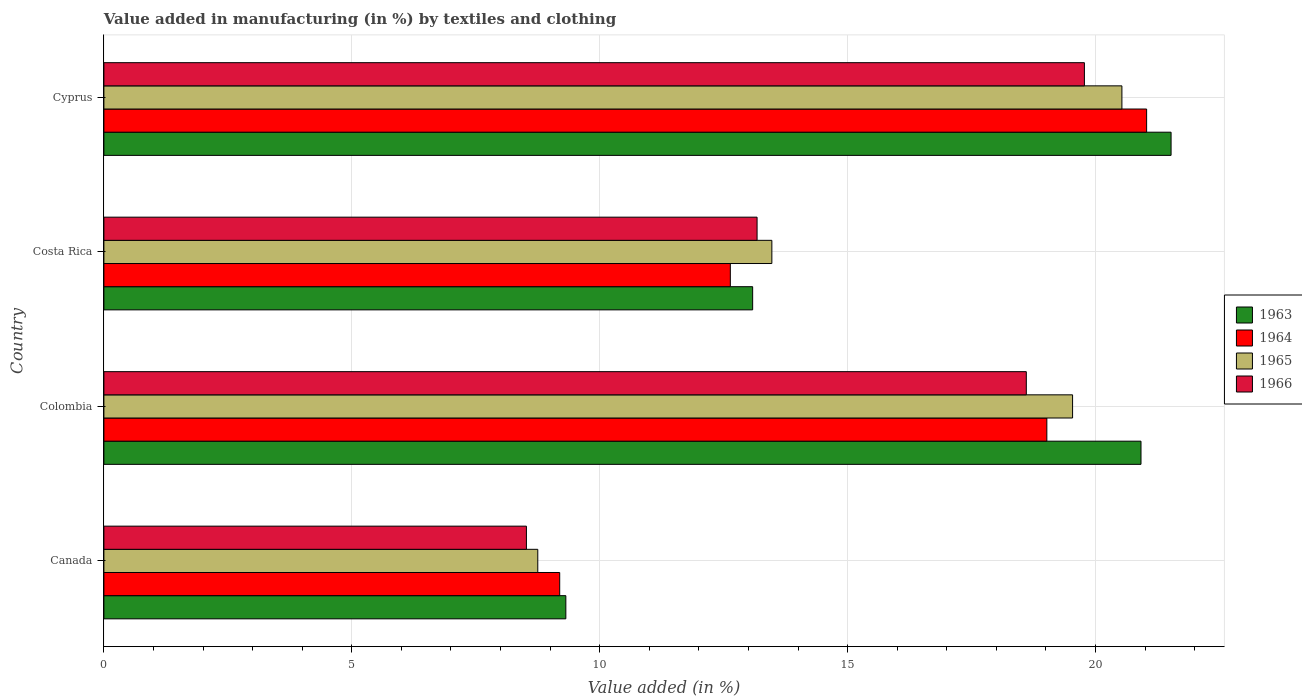How many different coloured bars are there?
Your answer should be very brief. 4. Are the number of bars per tick equal to the number of legend labels?
Give a very brief answer. Yes. How many bars are there on the 1st tick from the top?
Give a very brief answer. 4. What is the label of the 1st group of bars from the top?
Provide a short and direct response. Cyprus. What is the percentage of value added in manufacturing by textiles and clothing in 1965 in Cyprus?
Your answer should be very brief. 20.53. Across all countries, what is the maximum percentage of value added in manufacturing by textiles and clothing in 1965?
Your answer should be very brief. 20.53. Across all countries, what is the minimum percentage of value added in manufacturing by textiles and clothing in 1964?
Give a very brief answer. 9.19. In which country was the percentage of value added in manufacturing by textiles and clothing in 1965 maximum?
Ensure brevity in your answer.  Cyprus. What is the total percentage of value added in manufacturing by textiles and clothing in 1965 in the graph?
Offer a very short reply. 62.29. What is the difference between the percentage of value added in manufacturing by textiles and clothing in 1966 in Canada and that in Costa Rica?
Ensure brevity in your answer.  -4.65. What is the difference between the percentage of value added in manufacturing by textiles and clothing in 1964 in Cyprus and the percentage of value added in manufacturing by textiles and clothing in 1963 in Costa Rica?
Your response must be concise. 7.95. What is the average percentage of value added in manufacturing by textiles and clothing in 1964 per country?
Give a very brief answer. 15.47. What is the difference between the percentage of value added in manufacturing by textiles and clothing in 1963 and percentage of value added in manufacturing by textiles and clothing in 1964 in Costa Rica?
Offer a very short reply. 0.45. What is the ratio of the percentage of value added in manufacturing by textiles and clothing in 1966 in Canada to that in Colombia?
Offer a terse response. 0.46. Is the percentage of value added in manufacturing by textiles and clothing in 1966 in Canada less than that in Cyprus?
Ensure brevity in your answer.  Yes. What is the difference between the highest and the second highest percentage of value added in manufacturing by textiles and clothing in 1964?
Offer a very short reply. 2.01. What is the difference between the highest and the lowest percentage of value added in manufacturing by textiles and clothing in 1966?
Your answer should be compact. 11.25. In how many countries, is the percentage of value added in manufacturing by textiles and clothing in 1963 greater than the average percentage of value added in manufacturing by textiles and clothing in 1963 taken over all countries?
Keep it short and to the point. 2. What does the 1st bar from the top in Colombia represents?
Make the answer very short. 1966. What does the 2nd bar from the bottom in Colombia represents?
Provide a succinct answer. 1964. Is it the case that in every country, the sum of the percentage of value added in manufacturing by textiles and clothing in 1964 and percentage of value added in manufacturing by textiles and clothing in 1965 is greater than the percentage of value added in manufacturing by textiles and clothing in 1966?
Give a very brief answer. Yes. Are all the bars in the graph horizontal?
Provide a succinct answer. Yes. What is the difference between two consecutive major ticks on the X-axis?
Your response must be concise. 5. Are the values on the major ticks of X-axis written in scientific E-notation?
Your answer should be compact. No. Does the graph contain any zero values?
Provide a succinct answer. No. Does the graph contain grids?
Offer a terse response. Yes. How are the legend labels stacked?
Your answer should be very brief. Vertical. What is the title of the graph?
Give a very brief answer. Value added in manufacturing (in %) by textiles and clothing. Does "1978" appear as one of the legend labels in the graph?
Give a very brief answer. No. What is the label or title of the X-axis?
Provide a succinct answer. Value added (in %). What is the label or title of the Y-axis?
Offer a terse response. Country. What is the Value added (in %) in 1963 in Canada?
Ensure brevity in your answer.  9.32. What is the Value added (in %) in 1964 in Canada?
Ensure brevity in your answer.  9.19. What is the Value added (in %) of 1965 in Canada?
Offer a very short reply. 8.75. What is the Value added (in %) in 1966 in Canada?
Provide a succinct answer. 8.52. What is the Value added (in %) of 1963 in Colombia?
Ensure brevity in your answer.  20.92. What is the Value added (in %) of 1964 in Colombia?
Provide a succinct answer. 19.02. What is the Value added (in %) of 1965 in Colombia?
Give a very brief answer. 19.54. What is the Value added (in %) in 1966 in Colombia?
Offer a very short reply. 18.6. What is the Value added (in %) in 1963 in Costa Rica?
Your response must be concise. 13.08. What is the Value added (in %) of 1964 in Costa Rica?
Provide a succinct answer. 12.63. What is the Value added (in %) of 1965 in Costa Rica?
Your answer should be compact. 13.47. What is the Value added (in %) in 1966 in Costa Rica?
Provide a short and direct response. 13.17. What is the Value added (in %) in 1963 in Cyprus?
Provide a short and direct response. 21.52. What is the Value added (in %) of 1964 in Cyprus?
Your answer should be compact. 21.03. What is the Value added (in %) of 1965 in Cyprus?
Ensure brevity in your answer.  20.53. What is the Value added (in %) of 1966 in Cyprus?
Keep it short and to the point. 19.78. Across all countries, what is the maximum Value added (in %) in 1963?
Offer a very short reply. 21.52. Across all countries, what is the maximum Value added (in %) in 1964?
Your answer should be very brief. 21.03. Across all countries, what is the maximum Value added (in %) in 1965?
Make the answer very short. 20.53. Across all countries, what is the maximum Value added (in %) of 1966?
Provide a succinct answer. 19.78. Across all countries, what is the minimum Value added (in %) of 1963?
Provide a succinct answer. 9.32. Across all countries, what is the minimum Value added (in %) of 1964?
Your response must be concise. 9.19. Across all countries, what is the minimum Value added (in %) of 1965?
Ensure brevity in your answer.  8.75. Across all countries, what is the minimum Value added (in %) in 1966?
Keep it short and to the point. 8.52. What is the total Value added (in %) in 1963 in the graph?
Give a very brief answer. 64.84. What is the total Value added (in %) of 1964 in the graph?
Make the answer very short. 61.88. What is the total Value added (in %) of 1965 in the graph?
Your answer should be very brief. 62.29. What is the total Value added (in %) in 1966 in the graph?
Provide a succinct answer. 60.08. What is the difference between the Value added (in %) in 1963 in Canada and that in Colombia?
Your response must be concise. -11.6. What is the difference between the Value added (in %) in 1964 in Canada and that in Colombia?
Give a very brief answer. -9.82. What is the difference between the Value added (in %) of 1965 in Canada and that in Colombia?
Your answer should be very brief. -10.79. What is the difference between the Value added (in %) of 1966 in Canada and that in Colombia?
Offer a very short reply. -10.08. What is the difference between the Value added (in %) of 1963 in Canada and that in Costa Rica?
Your answer should be very brief. -3.77. What is the difference between the Value added (in %) of 1964 in Canada and that in Costa Rica?
Offer a very short reply. -3.44. What is the difference between the Value added (in %) of 1965 in Canada and that in Costa Rica?
Make the answer very short. -4.72. What is the difference between the Value added (in %) of 1966 in Canada and that in Costa Rica?
Make the answer very short. -4.65. What is the difference between the Value added (in %) in 1963 in Canada and that in Cyprus?
Provide a succinct answer. -12.21. What is the difference between the Value added (in %) in 1964 in Canada and that in Cyprus?
Offer a terse response. -11.84. What is the difference between the Value added (in %) of 1965 in Canada and that in Cyprus?
Offer a terse response. -11.78. What is the difference between the Value added (in %) in 1966 in Canada and that in Cyprus?
Your answer should be compact. -11.25. What is the difference between the Value added (in %) of 1963 in Colombia and that in Costa Rica?
Ensure brevity in your answer.  7.83. What is the difference between the Value added (in %) in 1964 in Colombia and that in Costa Rica?
Provide a succinct answer. 6.38. What is the difference between the Value added (in %) in 1965 in Colombia and that in Costa Rica?
Offer a very short reply. 6.06. What is the difference between the Value added (in %) of 1966 in Colombia and that in Costa Rica?
Ensure brevity in your answer.  5.43. What is the difference between the Value added (in %) of 1963 in Colombia and that in Cyprus?
Make the answer very short. -0.61. What is the difference between the Value added (in %) of 1964 in Colombia and that in Cyprus?
Keep it short and to the point. -2.01. What is the difference between the Value added (in %) in 1965 in Colombia and that in Cyprus?
Offer a terse response. -0.99. What is the difference between the Value added (in %) in 1966 in Colombia and that in Cyprus?
Provide a short and direct response. -1.17. What is the difference between the Value added (in %) of 1963 in Costa Rica and that in Cyprus?
Keep it short and to the point. -8.44. What is the difference between the Value added (in %) of 1964 in Costa Rica and that in Cyprus?
Provide a short and direct response. -8.4. What is the difference between the Value added (in %) in 1965 in Costa Rica and that in Cyprus?
Provide a succinct answer. -7.06. What is the difference between the Value added (in %) of 1966 in Costa Rica and that in Cyprus?
Ensure brevity in your answer.  -6.6. What is the difference between the Value added (in %) of 1963 in Canada and the Value added (in %) of 1964 in Colombia?
Your answer should be very brief. -9.7. What is the difference between the Value added (in %) in 1963 in Canada and the Value added (in %) in 1965 in Colombia?
Your answer should be very brief. -10.22. What is the difference between the Value added (in %) of 1963 in Canada and the Value added (in %) of 1966 in Colombia?
Provide a succinct answer. -9.29. What is the difference between the Value added (in %) in 1964 in Canada and the Value added (in %) in 1965 in Colombia?
Your response must be concise. -10.34. What is the difference between the Value added (in %) in 1964 in Canada and the Value added (in %) in 1966 in Colombia?
Offer a terse response. -9.41. What is the difference between the Value added (in %) in 1965 in Canada and the Value added (in %) in 1966 in Colombia?
Offer a very short reply. -9.85. What is the difference between the Value added (in %) of 1963 in Canada and the Value added (in %) of 1964 in Costa Rica?
Provide a short and direct response. -3.32. What is the difference between the Value added (in %) in 1963 in Canada and the Value added (in %) in 1965 in Costa Rica?
Provide a short and direct response. -4.16. What is the difference between the Value added (in %) in 1963 in Canada and the Value added (in %) in 1966 in Costa Rica?
Make the answer very short. -3.86. What is the difference between the Value added (in %) of 1964 in Canada and the Value added (in %) of 1965 in Costa Rica?
Give a very brief answer. -4.28. What is the difference between the Value added (in %) of 1964 in Canada and the Value added (in %) of 1966 in Costa Rica?
Keep it short and to the point. -3.98. What is the difference between the Value added (in %) of 1965 in Canada and the Value added (in %) of 1966 in Costa Rica?
Provide a short and direct response. -4.42. What is the difference between the Value added (in %) in 1963 in Canada and the Value added (in %) in 1964 in Cyprus?
Offer a very short reply. -11.71. What is the difference between the Value added (in %) of 1963 in Canada and the Value added (in %) of 1965 in Cyprus?
Offer a terse response. -11.21. What is the difference between the Value added (in %) of 1963 in Canada and the Value added (in %) of 1966 in Cyprus?
Make the answer very short. -10.46. What is the difference between the Value added (in %) of 1964 in Canada and the Value added (in %) of 1965 in Cyprus?
Give a very brief answer. -11.34. What is the difference between the Value added (in %) in 1964 in Canada and the Value added (in %) in 1966 in Cyprus?
Your response must be concise. -10.58. What is the difference between the Value added (in %) in 1965 in Canada and the Value added (in %) in 1966 in Cyprus?
Ensure brevity in your answer.  -11.02. What is the difference between the Value added (in %) in 1963 in Colombia and the Value added (in %) in 1964 in Costa Rica?
Offer a terse response. 8.28. What is the difference between the Value added (in %) of 1963 in Colombia and the Value added (in %) of 1965 in Costa Rica?
Offer a very short reply. 7.44. What is the difference between the Value added (in %) in 1963 in Colombia and the Value added (in %) in 1966 in Costa Rica?
Your response must be concise. 7.74. What is the difference between the Value added (in %) in 1964 in Colombia and the Value added (in %) in 1965 in Costa Rica?
Your response must be concise. 5.55. What is the difference between the Value added (in %) in 1964 in Colombia and the Value added (in %) in 1966 in Costa Rica?
Keep it short and to the point. 5.84. What is the difference between the Value added (in %) of 1965 in Colombia and the Value added (in %) of 1966 in Costa Rica?
Give a very brief answer. 6.36. What is the difference between the Value added (in %) of 1963 in Colombia and the Value added (in %) of 1964 in Cyprus?
Your answer should be compact. -0.11. What is the difference between the Value added (in %) of 1963 in Colombia and the Value added (in %) of 1965 in Cyprus?
Give a very brief answer. 0.39. What is the difference between the Value added (in %) in 1963 in Colombia and the Value added (in %) in 1966 in Cyprus?
Your answer should be very brief. 1.14. What is the difference between the Value added (in %) in 1964 in Colombia and the Value added (in %) in 1965 in Cyprus?
Offer a terse response. -1.51. What is the difference between the Value added (in %) of 1964 in Colombia and the Value added (in %) of 1966 in Cyprus?
Keep it short and to the point. -0.76. What is the difference between the Value added (in %) of 1965 in Colombia and the Value added (in %) of 1966 in Cyprus?
Provide a short and direct response. -0.24. What is the difference between the Value added (in %) in 1963 in Costa Rica and the Value added (in %) in 1964 in Cyprus?
Make the answer very short. -7.95. What is the difference between the Value added (in %) of 1963 in Costa Rica and the Value added (in %) of 1965 in Cyprus?
Your response must be concise. -7.45. What is the difference between the Value added (in %) of 1963 in Costa Rica and the Value added (in %) of 1966 in Cyprus?
Give a very brief answer. -6.69. What is the difference between the Value added (in %) in 1964 in Costa Rica and the Value added (in %) in 1965 in Cyprus?
Make the answer very short. -7.9. What is the difference between the Value added (in %) of 1964 in Costa Rica and the Value added (in %) of 1966 in Cyprus?
Your answer should be compact. -7.14. What is the difference between the Value added (in %) of 1965 in Costa Rica and the Value added (in %) of 1966 in Cyprus?
Provide a succinct answer. -6.3. What is the average Value added (in %) in 1963 per country?
Provide a short and direct response. 16.21. What is the average Value added (in %) of 1964 per country?
Your answer should be very brief. 15.47. What is the average Value added (in %) of 1965 per country?
Provide a succinct answer. 15.57. What is the average Value added (in %) of 1966 per country?
Your answer should be compact. 15.02. What is the difference between the Value added (in %) in 1963 and Value added (in %) in 1964 in Canada?
Your answer should be compact. 0.12. What is the difference between the Value added (in %) in 1963 and Value added (in %) in 1965 in Canada?
Keep it short and to the point. 0.57. What is the difference between the Value added (in %) of 1963 and Value added (in %) of 1966 in Canada?
Provide a short and direct response. 0.8. What is the difference between the Value added (in %) of 1964 and Value added (in %) of 1965 in Canada?
Your answer should be very brief. 0.44. What is the difference between the Value added (in %) of 1964 and Value added (in %) of 1966 in Canada?
Your answer should be very brief. 0.67. What is the difference between the Value added (in %) of 1965 and Value added (in %) of 1966 in Canada?
Ensure brevity in your answer.  0.23. What is the difference between the Value added (in %) in 1963 and Value added (in %) in 1964 in Colombia?
Provide a succinct answer. 1.9. What is the difference between the Value added (in %) of 1963 and Value added (in %) of 1965 in Colombia?
Make the answer very short. 1.38. What is the difference between the Value added (in %) of 1963 and Value added (in %) of 1966 in Colombia?
Make the answer very short. 2.31. What is the difference between the Value added (in %) in 1964 and Value added (in %) in 1965 in Colombia?
Keep it short and to the point. -0.52. What is the difference between the Value added (in %) of 1964 and Value added (in %) of 1966 in Colombia?
Your answer should be compact. 0.41. What is the difference between the Value added (in %) of 1965 and Value added (in %) of 1966 in Colombia?
Your answer should be very brief. 0.93. What is the difference between the Value added (in %) in 1963 and Value added (in %) in 1964 in Costa Rica?
Give a very brief answer. 0.45. What is the difference between the Value added (in %) in 1963 and Value added (in %) in 1965 in Costa Rica?
Offer a terse response. -0.39. What is the difference between the Value added (in %) in 1963 and Value added (in %) in 1966 in Costa Rica?
Provide a short and direct response. -0.09. What is the difference between the Value added (in %) in 1964 and Value added (in %) in 1965 in Costa Rica?
Make the answer very short. -0.84. What is the difference between the Value added (in %) in 1964 and Value added (in %) in 1966 in Costa Rica?
Your answer should be very brief. -0.54. What is the difference between the Value added (in %) of 1965 and Value added (in %) of 1966 in Costa Rica?
Offer a very short reply. 0.3. What is the difference between the Value added (in %) of 1963 and Value added (in %) of 1964 in Cyprus?
Your answer should be very brief. 0.49. What is the difference between the Value added (in %) of 1963 and Value added (in %) of 1966 in Cyprus?
Offer a terse response. 1.75. What is the difference between the Value added (in %) in 1964 and Value added (in %) in 1965 in Cyprus?
Offer a terse response. 0.5. What is the difference between the Value added (in %) in 1964 and Value added (in %) in 1966 in Cyprus?
Your answer should be very brief. 1.25. What is the difference between the Value added (in %) of 1965 and Value added (in %) of 1966 in Cyprus?
Your response must be concise. 0.76. What is the ratio of the Value added (in %) in 1963 in Canada to that in Colombia?
Ensure brevity in your answer.  0.45. What is the ratio of the Value added (in %) of 1964 in Canada to that in Colombia?
Provide a succinct answer. 0.48. What is the ratio of the Value added (in %) in 1965 in Canada to that in Colombia?
Offer a very short reply. 0.45. What is the ratio of the Value added (in %) in 1966 in Canada to that in Colombia?
Make the answer very short. 0.46. What is the ratio of the Value added (in %) of 1963 in Canada to that in Costa Rica?
Provide a succinct answer. 0.71. What is the ratio of the Value added (in %) of 1964 in Canada to that in Costa Rica?
Give a very brief answer. 0.73. What is the ratio of the Value added (in %) of 1965 in Canada to that in Costa Rica?
Provide a succinct answer. 0.65. What is the ratio of the Value added (in %) in 1966 in Canada to that in Costa Rica?
Give a very brief answer. 0.65. What is the ratio of the Value added (in %) of 1963 in Canada to that in Cyprus?
Your answer should be compact. 0.43. What is the ratio of the Value added (in %) of 1964 in Canada to that in Cyprus?
Ensure brevity in your answer.  0.44. What is the ratio of the Value added (in %) of 1965 in Canada to that in Cyprus?
Make the answer very short. 0.43. What is the ratio of the Value added (in %) of 1966 in Canada to that in Cyprus?
Ensure brevity in your answer.  0.43. What is the ratio of the Value added (in %) of 1963 in Colombia to that in Costa Rica?
Make the answer very short. 1.6. What is the ratio of the Value added (in %) in 1964 in Colombia to that in Costa Rica?
Provide a succinct answer. 1.51. What is the ratio of the Value added (in %) of 1965 in Colombia to that in Costa Rica?
Offer a terse response. 1.45. What is the ratio of the Value added (in %) of 1966 in Colombia to that in Costa Rica?
Your answer should be compact. 1.41. What is the ratio of the Value added (in %) of 1963 in Colombia to that in Cyprus?
Keep it short and to the point. 0.97. What is the ratio of the Value added (in %) of 1964 in Colombia to that in Cyprus?
Ensure brevity in your answer.  0.9. What is the ratio of the Value added (in %) in 1965 in Colombia to that in Cyprus?
Offer a very short reply. 0.95. What is the ratio of the Value added (in %) in 1966 in Colombia to that in Cyprus?
Give a very brief answer. 0.94. What is the ratio of the Value added (in %) of 1963 in Costa Rica to that in Cyprus?
Give a very brief answer. 0.61. What is the ratio of the Value added (in %) of 1964 in Costa Rica to that in Cyprus?
Ensure brevity in your answer.  0.6. What is the ratio of the Value added (in %) in 1965 in Costa Rica to that in Cyprus?
Provide a short and direct response. 0.66. What is the ratio of the Value added (in %) of 1966 in Costa Rica to that in Cyprus?
Provide a short and direct response. 0.67. What is the difference between the highest and the second highest Value added (in %) in 1963?
Keep it short and to the point. 0.61. What is the difference between the highest and the second highest Value added (in %) in 1964?
Keep it short and to the point. 2.01. What is the difference between the highest and the second highest Value added (in %) of 1966?
Offer a terse response. 1.17. What is the difference between the highest and the lowest Value added (in %) in 1963?
Provide a succinct answer. 12.21. What is the difference between the highest and the lowest Value added (in %) of 1964?
Keep it short and to the point. 11.84. What is the difference between the highest and the lowest Value added (in %) of 1965?
Your response must be concise. 11.78. What is the difference between the highest and the lowest Value added (in %) in 1966?
Your response must be concise. 11.25. 